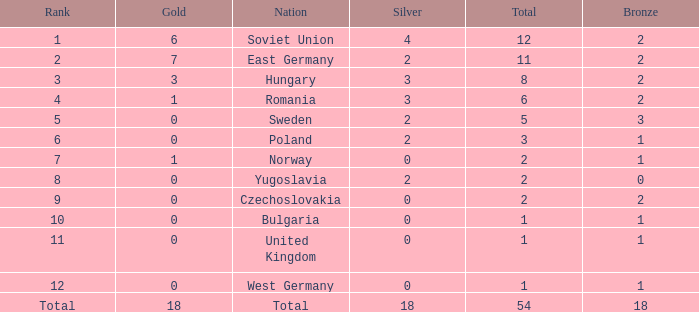What's the highest total of Romania when the bronze was less than 2? None. 